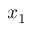Convert formula to latex. <formula><loc_0><loc_0><loc_500><loc_500>x _ { 1 }</formula> 